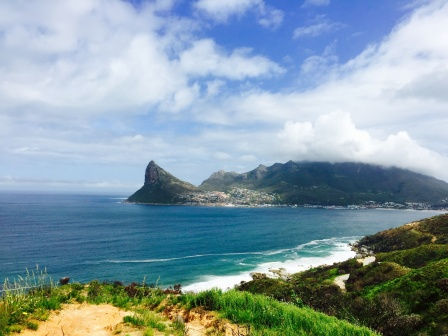Describe the atmosphere and feel of the location depicted in the photo. The atmosphere of the location in the photograph feels tranquil and idyllic. The bright, sunny sky and clear ocean waters suggest a warm, inviting climate perfect for relaxation or contemplation. The gentle sound of waves crashing against the shore adds a soothing auditory backdrop, enhancing the overall serenity. The lush green hills and rocky coastline provide a picturesque and adventurous touch, making the location feel like an ideal getaway for nature lovers and adventurers alike. The small town nestled among the hills adds a sense of community and charm, making the place feel welcoming and homely. What types of activities might people enjoy in this area? In such a beautiful coastal setting, people could indulge in a variety of activities. Beachgoers might enjoy swimming, sunbathing, or building sandcastles along the shore. The more adventurous could try surfing, boating, or para-sailing on the ocean waves. Hikers and nature enthusiasts might explore the green hills and rocky terrains, taking in the diverse flora and fauna. The small town could offer delightful local markets, quaint cafes, and cultural experiences. For those seeking tranquility, simply sitting by the shore and marveling at the vast expanse of the ocean, reading a book, or meditating could be profoundly rewarding. Additionally, photographers and artists might find endless inspiration in the stunning landscapes and vibrant natural beauty. Imagine the wildlife that might inhabit this area. What creatures could someone encounter? One might imagine a diverse array of wildlife in and around this beautiful coastal area. The ocean could be home to dolphins playfully leaping out of the water, curious sea turtles drifting lazily, and an array of colorful fish darting through the waves. Seagulls and other coastal birds might soar gracefully overhead, occasionally diving into the ocean for a meal. On land, the lush green hills could be rife with small mammals like rabbits or foxes, while the rocky terrain might harbor various reptiles such as lizards or snakes basking in the sun. In the vegetation surrounding the town, one might hear the songs of different bird species, from melodious songbirds to the raucous calls of crows. At night, the scene could be transformed with the chorus of crickets and the distant calls of owls or other nocturnal creatures, creating a vibrant symphony of natural sounds. If an artist decided to paint this scene, what elements do you think they would emphasize? An artist seeking to capture this scene might emphasize the vivid contrasts and harmonious balance between different elements in the landscape. The vast, deep blue of the ocean could be highlighted with textured waves capturing the motion and energy of the water. The coastline's lush green hills and rocky outcrops might be rendered with rich, earthy tones and varied brushstrokes to convey their rugged beauty. The small town, although distant and indistinct, could be depicted with soft, inviting strokes to suggest warmth and community. The clear blue sky and fluffy white clouds would likely be painted with light, airy touches to evoke the serene, sunlit atmosphere. The interplay of light and shadow throughout the scene would be crucial in portraying the warmth and depth of the landscape, from the sparkling highlights on the waves to the dappled shade on the hills. Overall, the artist might strive to create a sense of peaceful coexistence between natural beauty and human presence, evoking both tranquility and wonder in the viewer. 